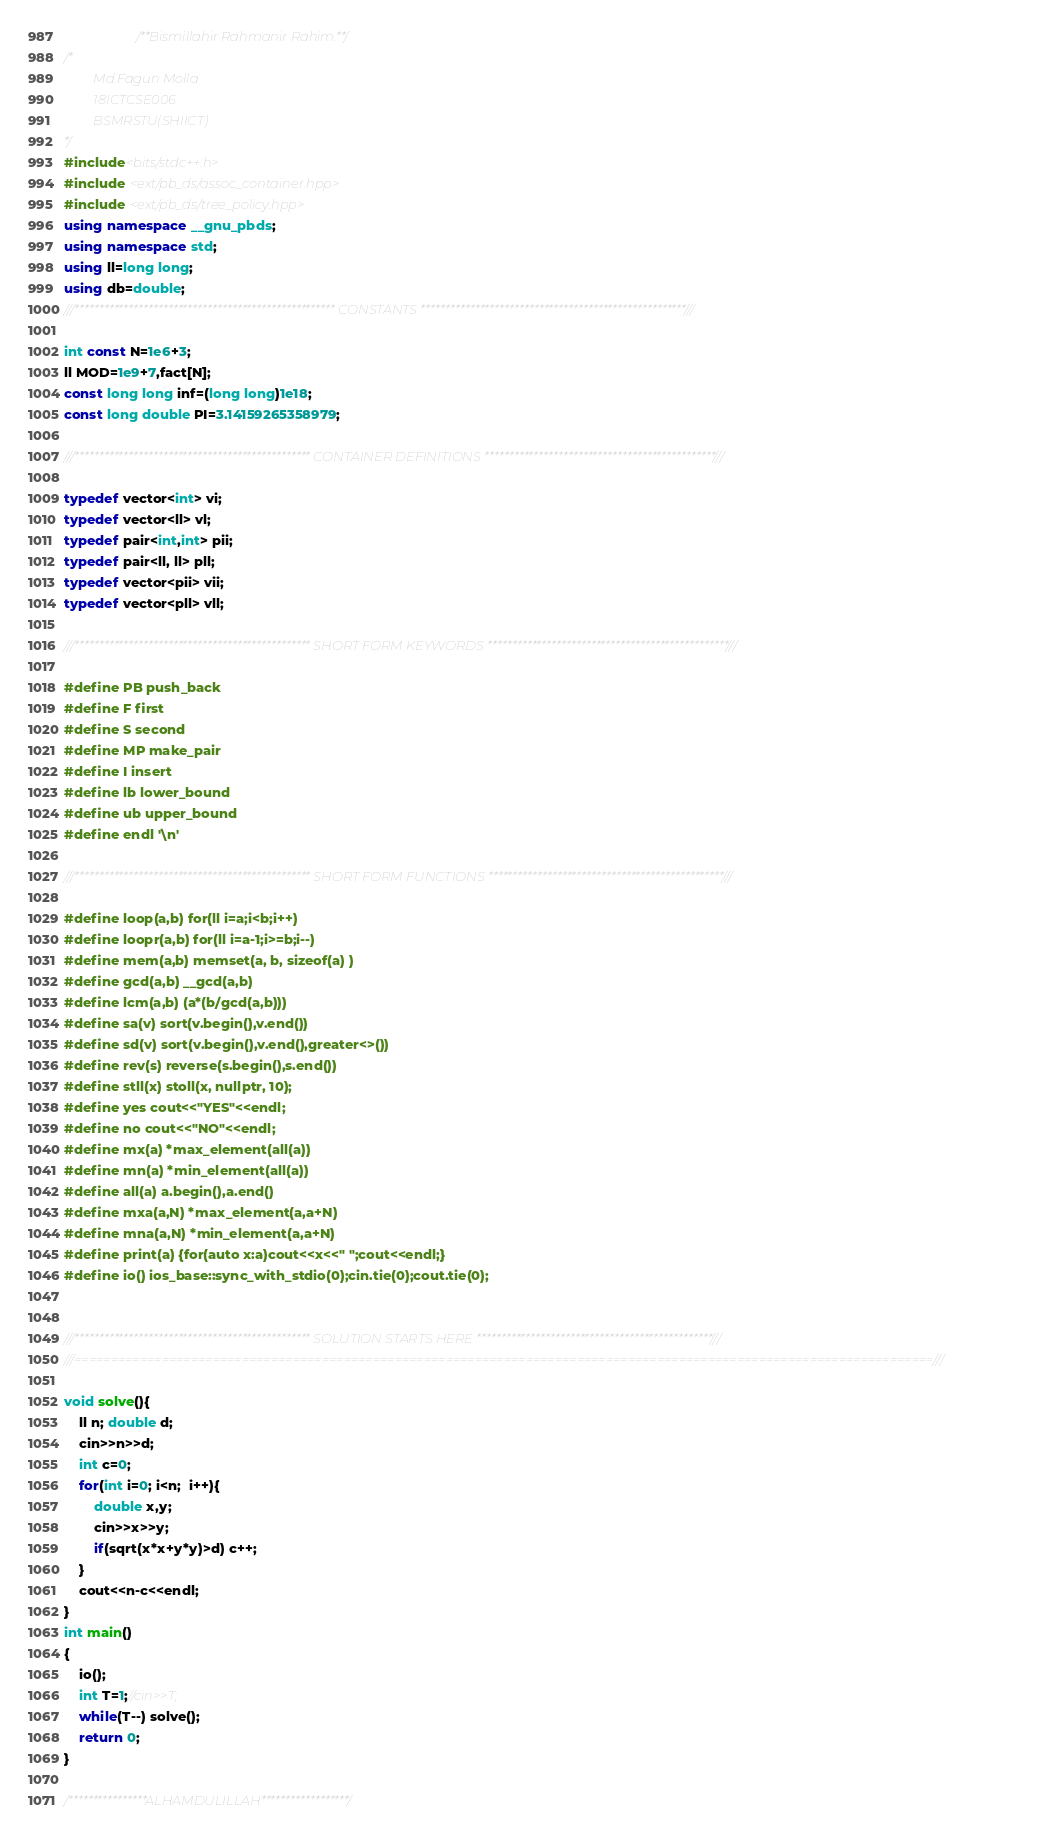Convert code to text. <code><loc_0><loc_0><loc_500><loc_500><_C++_>                   /**Bismillahir Rahmanir Rahim.**/
/*
         Md.Fagun Molla
         18ICTCSE006
         BSMRSTU(SHIICT)
*/
#include<bits/stdc++.h>
#include <ext/pb_ds/assoc_container.hpp>
#include <ext/pb_ds/tree_policy.hpp>
using namespace __gnu_pbds;
using namespace std;
using ll=long long;
using db=double;
///***************************************************** CONSTANTS ******************************************************///

int const N=1e6+3;
ll MOD=1e9+7,fact[N];
const long long inf=(long long)1e18;
const long double PI=3.14159265358979;

///************************************************ CONTAINER DEFINITIONS ***********************************************///

typedef vector<int> vi;
typedef vector<ll> vl;
typedef pair<int,int> pii;
typedef pair<ll, ll> pll;
typedef vector<pii> vii;
typedef vector<pll> vll;

///************************************************ SHORT FORM KEYWORDS *************************************************///

#define PB push_back
#define F first
#define S second
#define MP make_pair
#define I insert
#define lb lower_bound
#define ub upper_bound
#define endl '\n'

///************************************************ SHORT FORM FUNCTIONS ************************************************///

#define loop(a,b) for(ll i=a;i<b;i++)
#define loopr(a,b) for(ll i=a-1;i>=b;i--)
#define mem(a,b) memset(a, b, sizeof(a) )
#define gcd(a,b) __gcd(a,b)
#define lcm(a,b) (a*(b/gcd(a,b)))
#define sa(v) sort(v.begin(),v.end())
#define sd(v) sort(v.begin(),v.end(),greater<>())
#define rev(s) reverse(s.begin(),s.end())
#define stll(x) stoll(x, nullptr, 10);
#define yes cout<<"YES"<<endl;
#define no cout<<"NO"<<endl;
#define mx(a) *max_element(all(a))
#define mn(a) *min_element(all(a))
#define all(a) a.begin(),a.end()
#define mxa(a,N) *max_element(a,a+N)
#define mna(a,N) *min_element(a,a+N)
#define print(a) {for(auto x:a)cout<<x<<" ";cout<<endl;}
#define io() ios_base::sync_with_stdio(0);cin.tie(0);cout.tie(0);


///************************************************ SOLUTION STARTS HERE ************************************************///
///======================================================================================================================///

void solve(){
	ll n; double d;
	cin>>n>>d;
	int c=0;
	for(int i=0; i<n;  i++){
		double x,y;
		cin>>x>>y;
		if(sqrt(x*x+y*y)>d) c++;
	}
	cout<<n-c<<endl;
}
int main()
{
    io();
    int T=1;//cin>>T;
    while(T--) solve();
    return 0;
}

/****************ALHAMDULILLAH******************/
</code> 